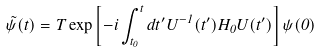<formula> <loc_0><loc_0><loc_500><loc_500>\tilde { \psi } ( t ) = T \exp \left [ - i \int ^ { t } _ { t _ { 0 } } d t ^ { \prime } U ^ { - 1 } ( t ^ { \prime } ) H _ { 0 } U ( t ^ { \prime } ) \right ] \psi ( 0 )</formula> 